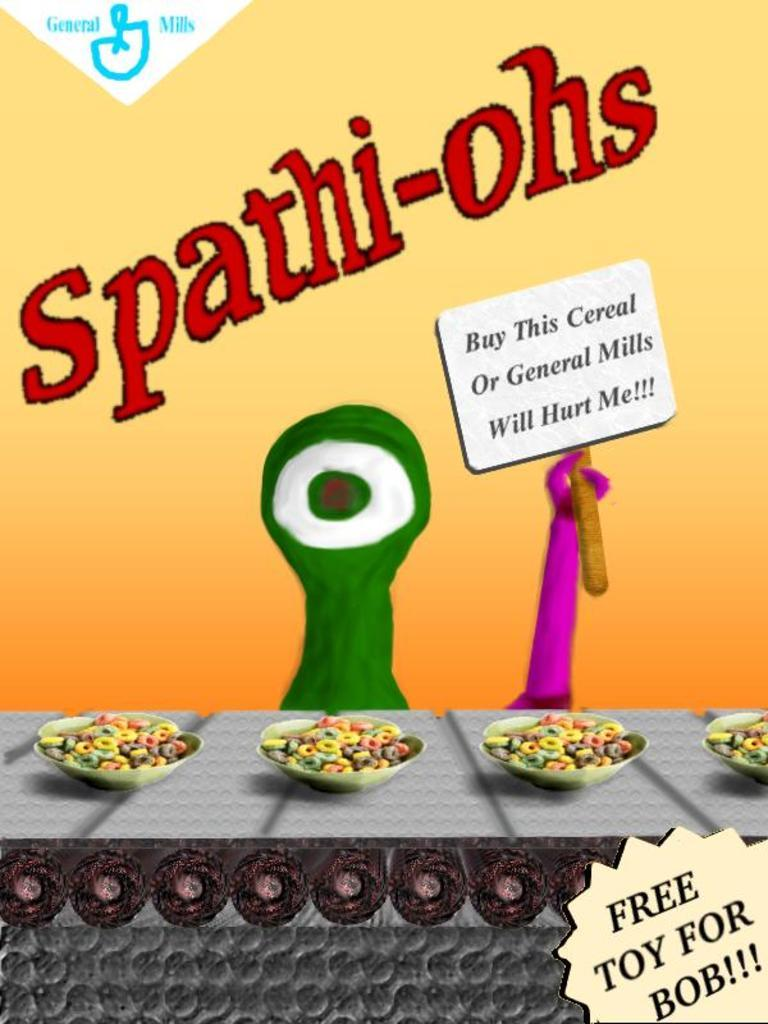What type of advertisement is shown in the image? The image contains a cereal advertisement. What can be seen in the cereal advertisement? There are bowls of cereals in the advertisement. What is the name of the cereal being advertised? The name of the cereal is Spat hi-ohs. What songs are being sung by the cereal in the image? There is no indication in the image that the cereal is singing songs, as it is an inanimate object. --- Facts: 1. There is a person holding a book in the image. 2. The person is sitting on a chair. 3. The book has a blue cover. 4. The chair is made of wood. Absurd Topics: dance, ocean, volcano Conversation: What is the person in the image doing? The person in the image is holding a book. Where is the person sitting in the image? The person is sitting on a chair. What color is the book's cover? The book has a blue cover. What material is the chair made of? The chair is made of wood. Reasoning: Let's think step by step in order to produce the conversation. We start by identifying the main subject of the image, which is a person holding a book. Then, we describe the person's position and location, noting that they are sitting on a chair. Next, we focus on the book's appearance, mentioning its blue cover. Finally, we describe the chair's material, which is wood. Absurd Question/Answer: Can you see any dancing volcanoes in the image? There are no dancing volcanoes present in the image; it features a person holding a book and sitting on a wooden chair. 